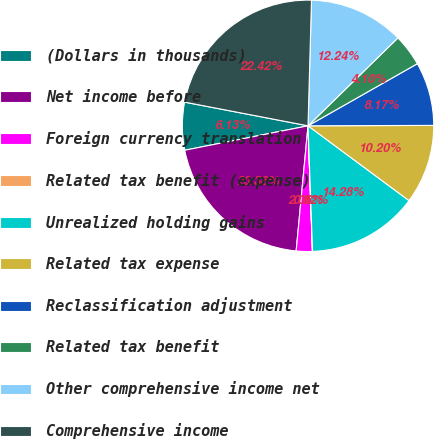Convert chart. <chart><loc_0><loc_0><loc_500><loc_500><pie_chart><fcel>(Dollars in thousands)<fcel>Net income before<fcel>Foreign currency translation<fcel>Related tax benefit (expense)<fcel>Unrealized holding gains<fcel>Related tax expense<fcel>Reclassification adjustment<fcel>Related tax benefit<fcel>Other comprehensive income net<fcel>Comprehensive income<nl><fcel>6.13%<fcel>20.38%<fcel>2.06%<fcel>0.02%<fcel>14.28%<fcel>10.2%<fcel>8.17%<fcel>4.1%<fcel>12.24%<fcel>22.42%<nl></chart> 